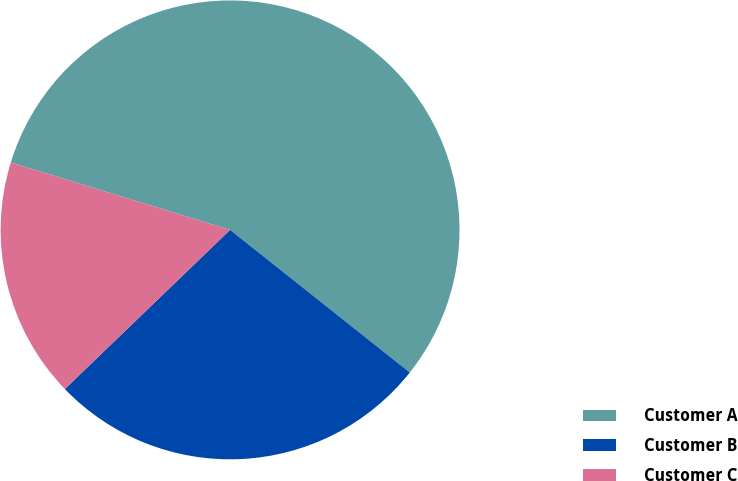<chart> <loc_0><loc_0><loc_500><loc_500><pie_chart><fcel>Customer A<fcel>Customer B<fcel>Customer C<nl><fcel>55.93%<fcel>27.12%<fcel>16.95%<nl></chart> 